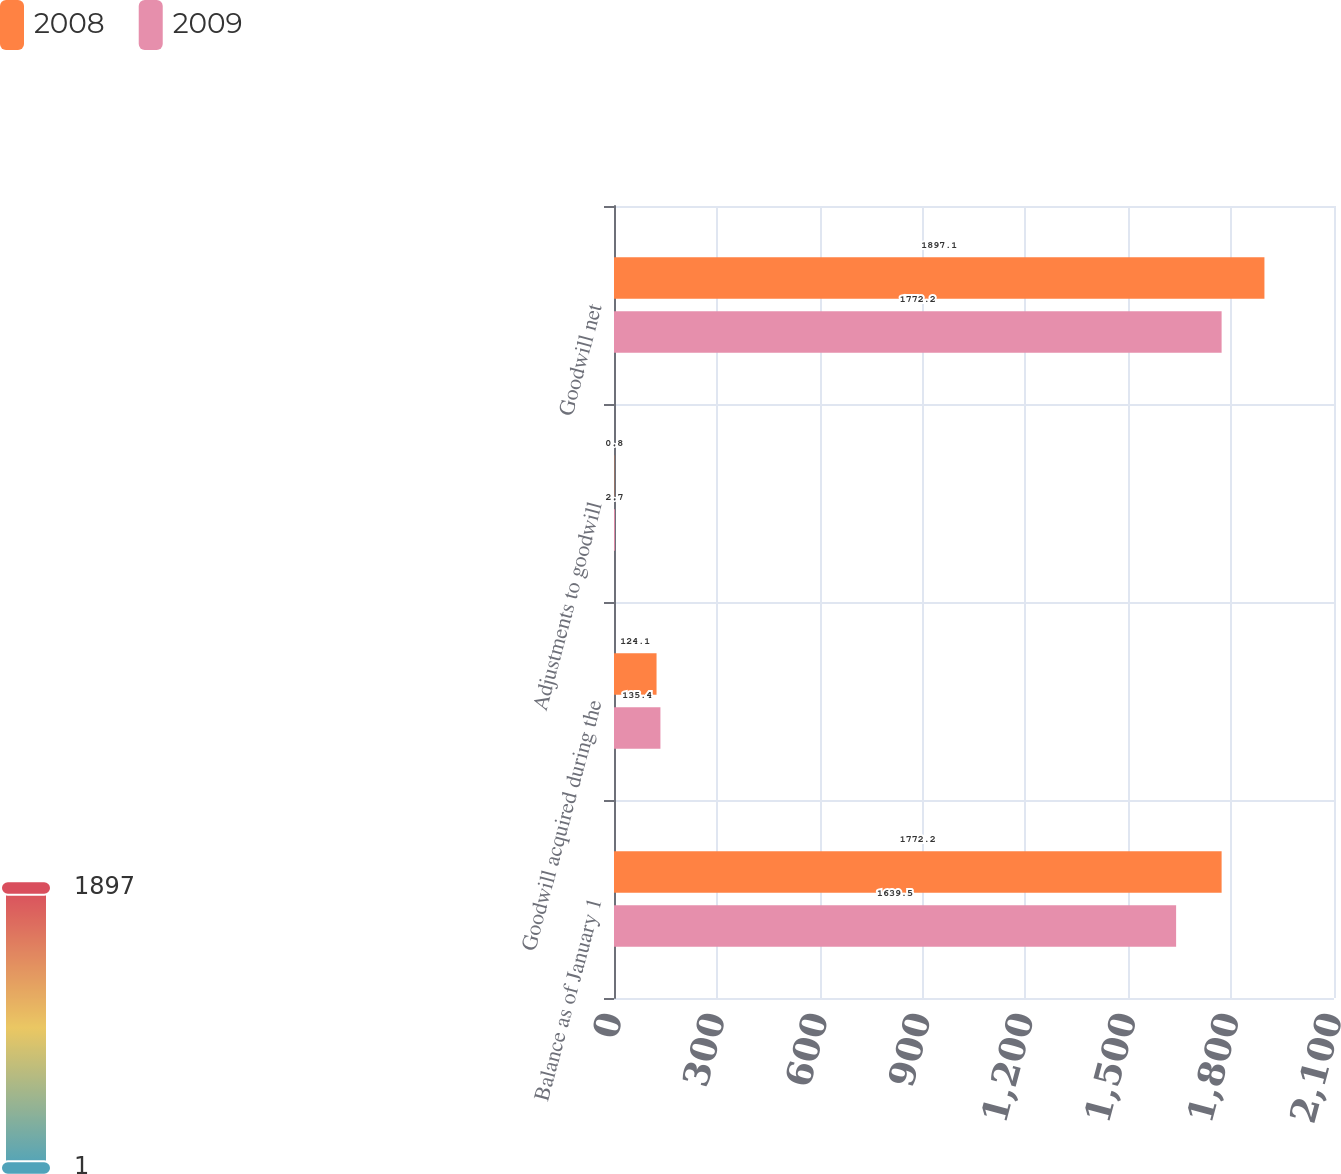Convert chart. <chart><loc_0><loc_0><loc_500><loc_500><stacked_bar_chart><ecel><fcel>Balance as of January 1<fcel>Goodwill acquired during the<fcel>Adjustments to goodwill<fcel>Goodwill net<nl><fcel>2008<fcel>1772.2<fcel>124.1<fcel>0.8<fcel>1897.1<nl><fcel>2009<fcel>1639.5<fcel>135.4<fcel>2.7<fcel>1772.2<nl></chart> 